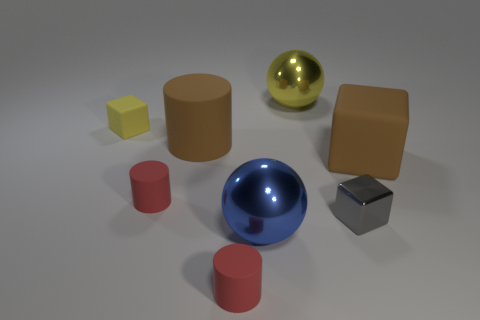There is a large brown thing that is the same material as the big cube; what is its shape?
Offer a terse response. Cylinder. Are there any other things that have the same shape as the small shiny object?
Provide a short and direct response. Yes. What is the color of the cube that is behind the small gray thing and right of the big blue metal object?
Provide a succinct answer. Brown. How many cylinders are either tiny yellow objects or big brown things?
Your response must be concise. 1. What number of red objects are the same size as the brown cube?
Give a very brief answer. 0. How many big blue objects are behind the big matte object that is left of the brown matte cube?
Your answer should be very brief. 0. How big is the metal thing that is both on the left side of the gray metal object and in front of the brown matte cylinder?
Your answer should be very brief. Large. Is the number of red matte objects greater than the number of tiny yellow cubes?
Keep it short and to the point. Yes. Is there a small metal block that has the same color as the tiny shiny object?
Your answer should be very brief. No. Do the brown rubber object that is on the left side of the yellow ball and the tiny yellow matte cube have the same size?
Ensure brevity in your answer.  No. 